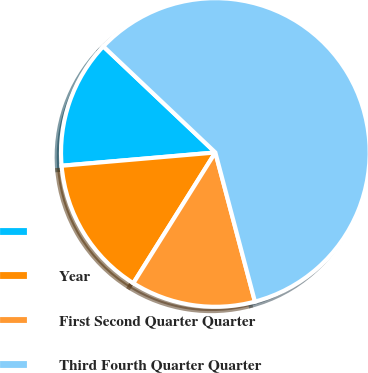Convert chart to OTSL. <chart><loc_0><loc_0><loc_500><loc_500><pie_chart><ecel><fcel>Year<fcel>First Second Quarter Quarter<fcel>Third Fourth Quarter Quarter<nl><fcel>13.44%<fcel>14.71%<fcel>13.05%<fcel>58.8%<nl></chart> 